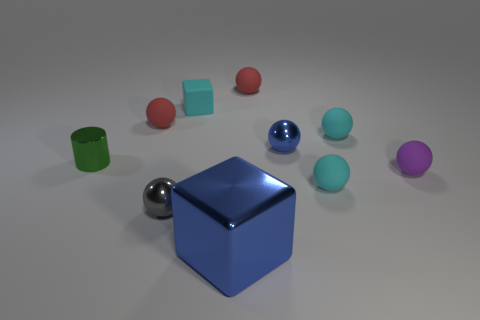There is a tiny block; does it have the same color as the small rubber ball that is in front of the purple thing?
Your response must be concise. Yes. What number of balls have the same color as the big object?
Offer a terse response. 1. Is there any other thing that has the same color as the big object?
Make the answer very short. Yes. What color is the other metal thing that is the same shape as the gray object?
Your answer should be compact. Blue. Are there more big blue objects left of the tiny blue shiny thing than green matte things?
Keep it short and to the point. Yes. There is a tiny metal sphere that is left of the large blue metal block; what color is it?
Keep it short and to the point. Gray. Do the green cylinder and the blue block have the same size?
Offer a terse response. No. What size is the purple ball?
Make the answer very short. Small. Are there more big yellow spheres than shiny cubes?
Keep it short and to the point. No. There is a cube that is behind the tiny cyan sphere that is in front of the blue thing that is to the right of the shiny block; what is its color?
Your response must be concise. Cyan. 